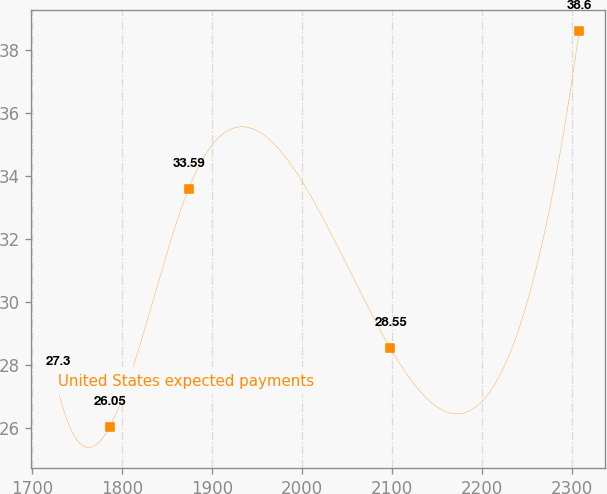Convert chart to OTSL. <chart><loc_0><loc_0><loc_500><loc_500><line_chart><ecel><fcel>United States expected payments<nl><fcel>1728.35<fcel>27.3<nl><fcel>1786.31<fcel>26.05<nl><fcel>1874.02<fcel>33.59<nl><fcel>2098.13<fcel>28.55<nl><fcel>2307.91<fcel>38.6<nl></chart> 